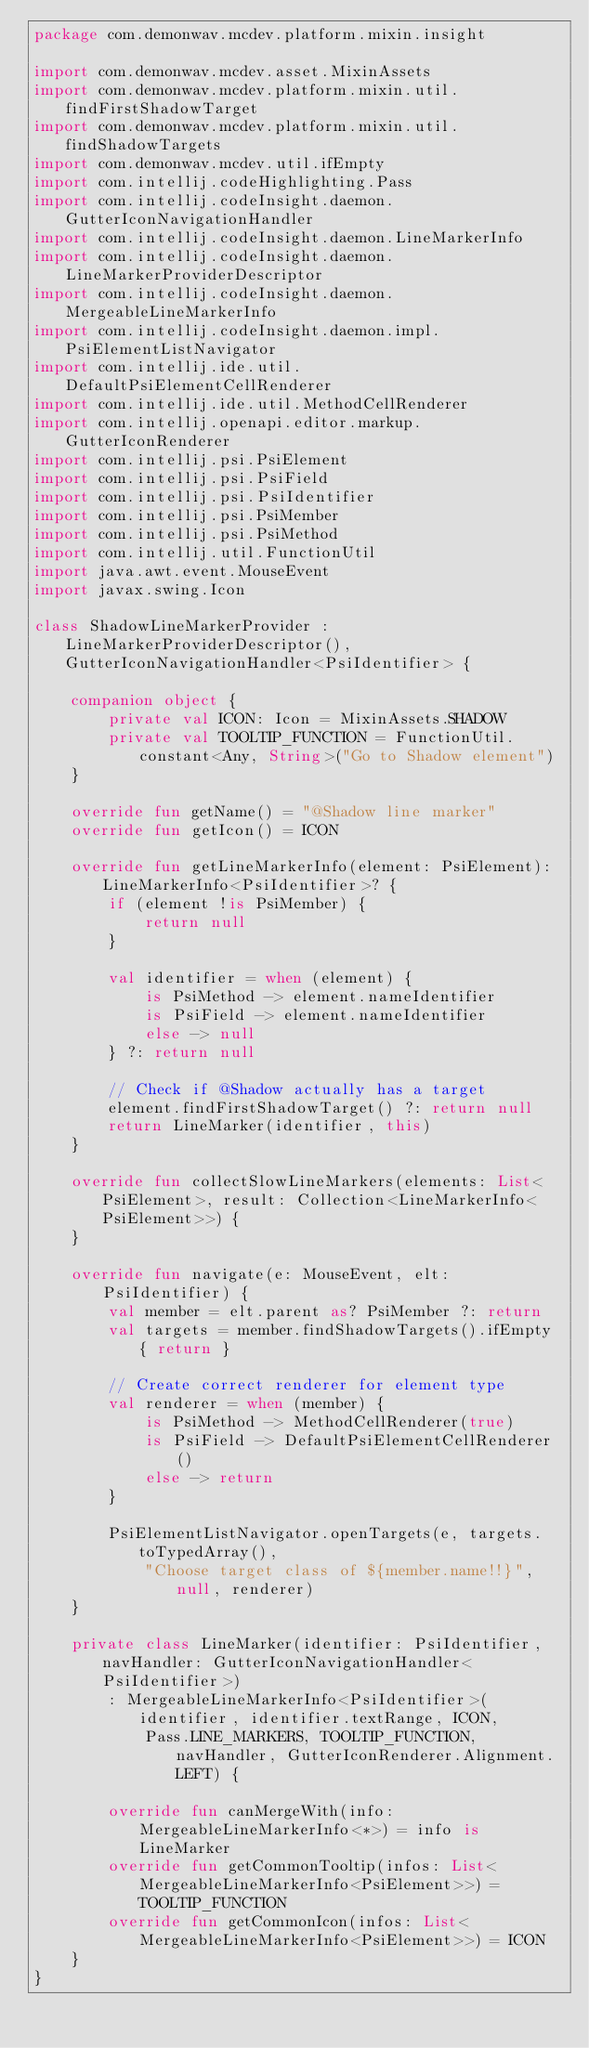Convert code to text. <code><loc_0><loc_0><loc_500><loc_500><_Kotlin_>package com.demonwav.mcdev.platform.mixin.insight

import com.demonwav.mcdev.asset.MixinAssets
import com.demonwav.mcdev.platform.mixin.util.findFirstShadowTarget
import com.demonwav.mcdev.platform.mixin.util.findShadowTargets
import com.demonwav.mcdev.util.ifEmpty
import com.intellij.codeHighlighting.Pass
import com.intellij.codeInsight.daemon.GutterIconNavigationHandler
import com.intellij.codeInsight.daemon.LineMarkerInfo
import com.intellij.codeInsight.daemon.LineMarkerProviderDescriptor
import com.intellij.codeInsight.daemon.MergeableLineMarkerInfo
import com.intellij.codeInsight.daemon.impl.PsiElementListNavigator
import com.intellij.ide.util.DefaultPsiElementCellRenderer
import com.intellij.ide.util.MethodCellRenderer
import com.intellij.openapi.editor.markup.GutterIconRenderer
import com.intellij.psi.PsiElement
import com.intellij.psi.PsiField
import com.intellij.psi.PsiIdentifier
import com.intellij.psi.PsiMember
import com.intellij.psi.PsiMethod
import com.intellij.util.FunctionUtil
import java.awt.event.MouseEvent
import javax.swing.Icon

class ShadowLineMarkerProvider : LineMarkerProviderDescriptor(), GutterIconNavigationHandler<PsiIdentifier> {

    companion object {
        private val ICON: Icon = MixinAssets.SHADOW
        private val TOOLTIP_FUNCTION = FunctionUtil.constant<Any, String>("Go to Shadow element")
    }

    override fun getName() = "@Shadow line marker"
    override fun getIcon() = ICON

    override fun getLineMarkerInfo(element: PsiElement): LineMarkerInfo<PsiIdentifier>? {
        if (element !is PsiMember) {
            return null
        }

        val identifier = when (element) {
            is PsiMethod -> element.nameIdentifier
            is PsiField -> element.nameIdentifier
            else -> null
        } ?: return null

        // Check if @Shadow actually has a target
        element.findFirstShadowTarget() ?: return null
        return LineMarker(identifier, this)
    }

    override fun collectSlowLineMarkers(elements: List<PsiElement>, result: Collection<LineMarkerInfo<PsiElement>>) {
    }

    override fun navigate(e: MouseEvent, elt: PsiIdentifier) {
        val member = elt.parent as? PsiMember ?: return
        val targets = member.findShadowTargets().ifEmpty { return }

        // Create correct renderer for element type
        val renderer = when (member) {
            is PsiMethod -> MethodCellRenderer(true)
            is PsiField -> DefaultPsiElementCellRenderer()
            else -> return
        }

        PsiElementListNavigator.openTargets(e, targets.toTypedArray(),
            "Choose target class of ${member.name!!}", null, renderer)
    }

    private class LineMarker(identifier: PsiIdentifier, navHandler: GutterIconNavigationHandler<PsiIdentifier>)
        : MergeableLineMarkerInfo<PsiIdentifier>(identifier, identifier.textRange, ICON,
            Pass.LINE_MARKERS, TOOLTIP_FUNCTION, navHandler, GutterIconRenderer.Alignment.LEFT) {

        override fun canMergeWith(info: MergeableLineMarkerInfo<*>) = info is LineMarker
        override fun getCommonTooltip(infos: List<MergeableLineMarkerInfo<PsiElement>>) = TOOLTIP_FUNCTION
        override fun getCommonIcon(infos: List<MergeableLineMarkerInfo<PsiElement>>) = ICON
    }
}
</code> 